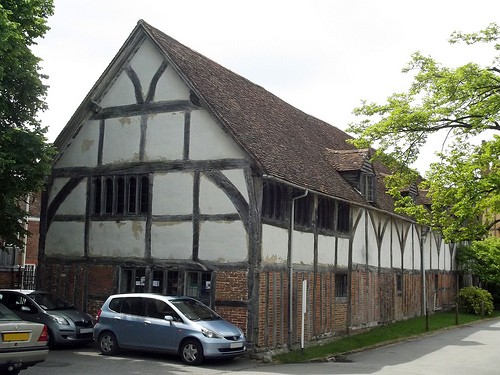<image>
Is there a house in front of the van? No. The house is not in front of the van. The spatial positioning shows a different relationship between these objects. 